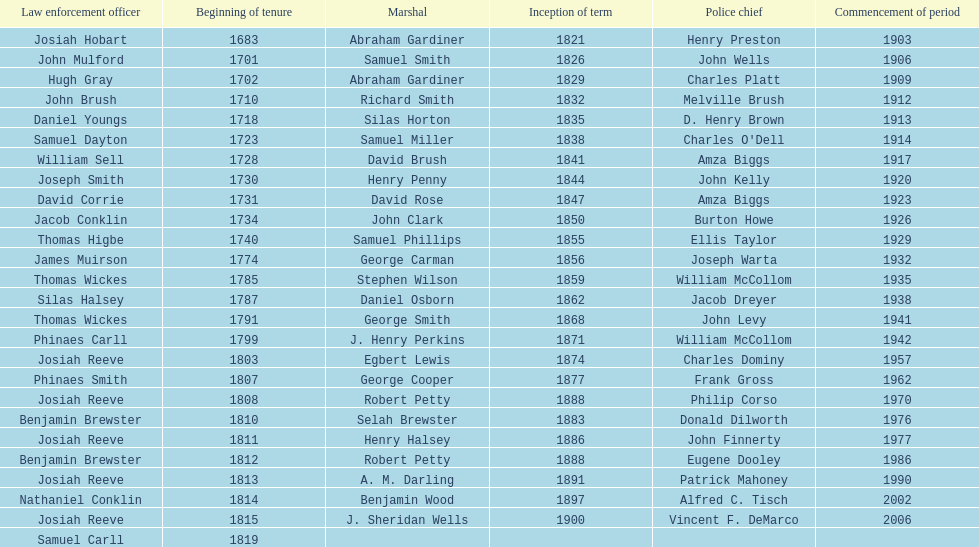How many sheriff's have the last name biggs? 1. 